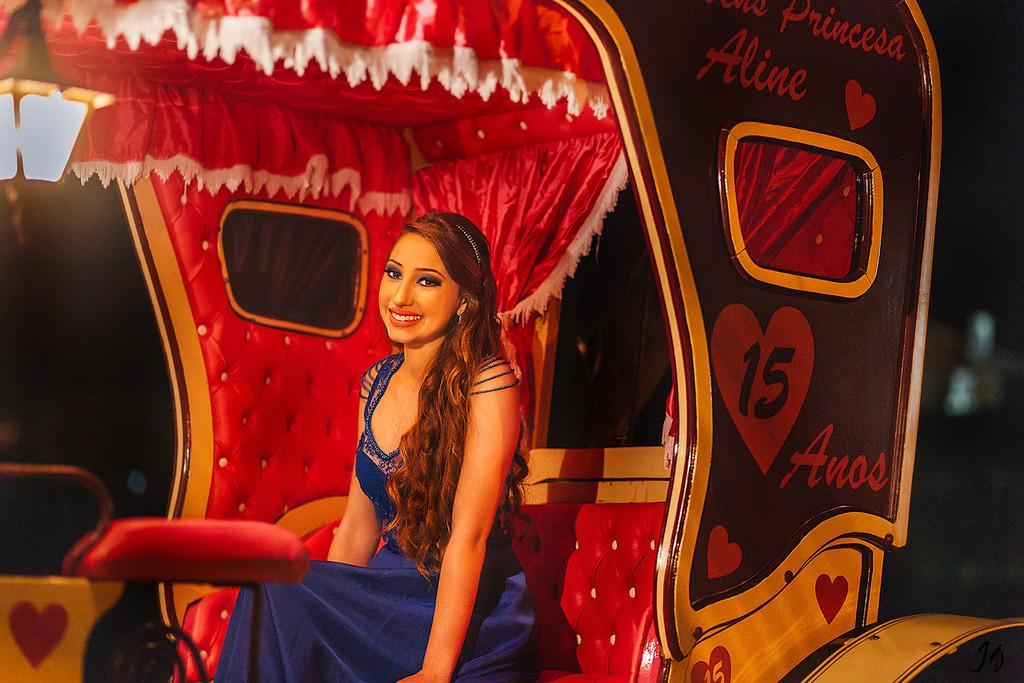In one or two sentences, can you explain what this image depicts? In this picture we can see a woman sitting in a rickshaw and in the background we can see it is dark. 